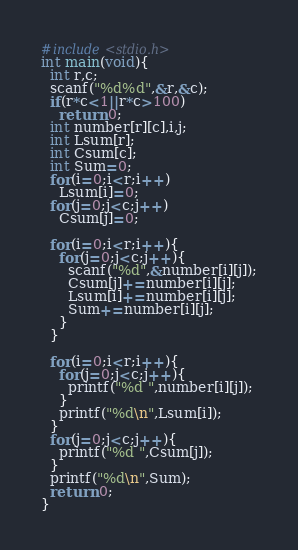Convert code to text. <code><loc_0><loc_0><loc_500><loc_500><_C_>#include<stdio.h>
int main(void){
  int r,c;
  scanf("%d%d",&r,&c);
  if(r*c<1||r*c>100)
    return 0;
  int number[r][c],i,j;
  int Lsum[r];
  int Csum[c];
  int Sum=0;
  for(i=0;i<r;i++)
    Lsum[i]=0;
  for(j=0;j<c;j++)
    Csum[j]=0;

  for(i=0;i<r;i++){
    for(j=0;j<c;j++){
      scanf("%d",&number[i][j]);
      Csum[j]+=number[i][j];
      Lsum[i]+=number[i][j];
      Sum+=number[i][j];
    }
  }

  for(i=0;i<r;i++){
    for(j=0;j<c;j++){
      printf("%d ",number[i][j]);
    }
    printf("%d\n",Lsum[i]);
  }
  for(j=0;j<c;j++){
    printf("%d ",Csum[j]);
  }
  printf("%d\n",Sum);
  return 0;
}</code> 